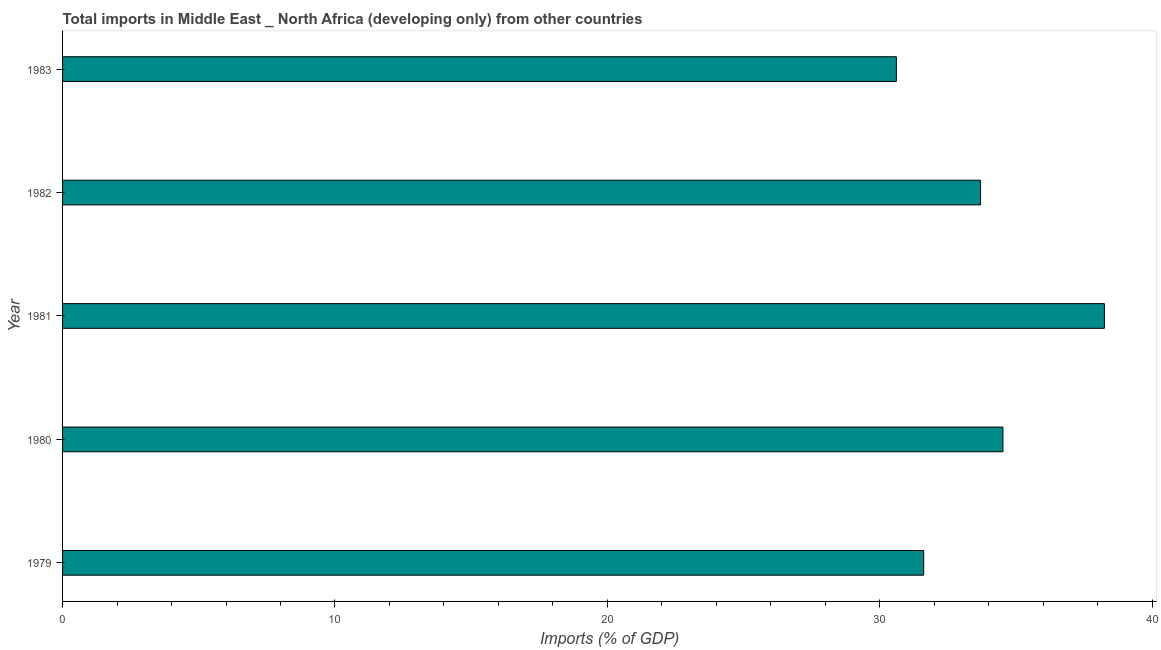What is the title of the graph?
Your response must be concise. Total imports in Middle East _ North Africa (developing only) from other countries. What is the label or title of the X-axis?
Your response must be concise. Imports (% of GDP). What is the label or title of the Y-axis?
Ensure brevity in your answer.  Year. What is the total imports in 1980?
Provide a succinct answer. 34.52. Across all years, what is the maximum total imports?
Keep it short and to the point. 38.25. Across all years, what is the minimum total imports?
Offer a very short reply. 30.61. In which year was the total imports minimum?
Give a very brief answer. 1983. What is the sum of the total imports?
Ensure brevity in your answer.  168.68. What is the difference between the total imports in 1980 and 1982?
Keep it short and to the point. 0.82. What is the average total imports per year?
Your answer should be compact. 33.74. What is the median total imports?
Your answer should be compact. 33.7. What is the ratio of the total imports in 1980 to that in 1983?
Keep it short and to the point. 1.13. Is the total imports in 1979 less than that in 1981?
Your answer should be compact. Yes. What is the difference between the highest and the second highest total imports?
Give a very brief answer. 3.73. Is the sum of the total imports in 1980 and 1981 greater than the maximum total imports across all years?
Your response must be concise. Yes. What is the difference between the highest and the lowest total imports?
Ensure brevity in your answer.  7.64. In how many years, is the total imports greater than the average total imports taken over all years?
Offer a terse response. 2. Are all the bars in the graph horizontal?
Ensure brevity in your answer.  Yes. How many years are there in the graph?
Ensure brevity in your answer.  5. What is the difference between two consecutive major ticks on the X-axis?
Your answer should be compact. 10. What is the Imports (% of GDP) of 1979?
Offer a terse response. 31.61. What is the Imports (% of GDP) in 1980?
Your answer should be very brief. 34.52. What is the Imports (% of GDP) in 1981?
Make the answer very short. 38.25. What is the Imports (% of GDP) of 1982?
Make the answer very short. 33.7. What is the Imports (% of GDP) in 1983?
Provide a short and direct response. 30.61. What is the difference between the Imports (% of GDP) in 1979 and 1980?
Keep it short and to the point. -2.91. What is the difference between the Imports (% of GDP) in 1979 and 1981?
Give a very brief answer. -6.63. What is the difference between the Imports (% of GDP) in 1979 and 1982?
Your answer should be very brief. -2.09. What is the difference between the Imports (% of GDP) in 1979 and 1983?
Provide a short and direct response. 1. What is the difference between the Imports (% of GDP) in 1980 and 1981?
Make the answer very short. -3.73. What is the difference between the Imports (% of GDP) in 1980 and 1982?
Your answer should be compact. 0.82. What is the difference between the Imports (% of GDP) in 1980 and 1983?
Make the answer very short. 3.91. What is the difference between the Imports (% of GDP) in 1981 and 1982?
Your answer should be compact. 4.55. What is the difference between the Imports (% of GDP) in 1981 and 1983?
Offer a very short reply. 7.64. What is the difference between the Imports (% of GDP) in 1982 and 1983?
Keep it short and to the point. 3.09. What is the ratio of the Imports (% of GDP) in 1979 to that in 1980?
Your response must be concise. 0.92. What is the ratio of the Imports (% of GDP) in 1979 to that in 1981?
Offer a terse response. 0.83. What is the ratio of the Imports (% of GDP) in 1979 to that in 1982?
Your answer should be compact. 0.94. What is the ratio of the Imports (% of GDP) in 1979 to that in 1983?
Keep it short and to the point. 1.03. What is the ratio of the Imports (% of GDP) in 1980 to that in 1981?
Provide a short and direct response. 0.9. What is the ratio of the Imports (% of GDP) in 1980 to that in 1982?
Your answer should be very brief. 1.02. What is the ratio of the Imports (% of GDP) in 1980 to that in 1983?
Your response must be concise. 1.13. What is the ratio of the Imports (% of GDP) in 1981 to that in 1982?
Your answer should be very brief. 1.14. What is the ratio of the Imports (% of GDP) in 1982 to that in 1983?
Your answer should be compact. 1.1. 